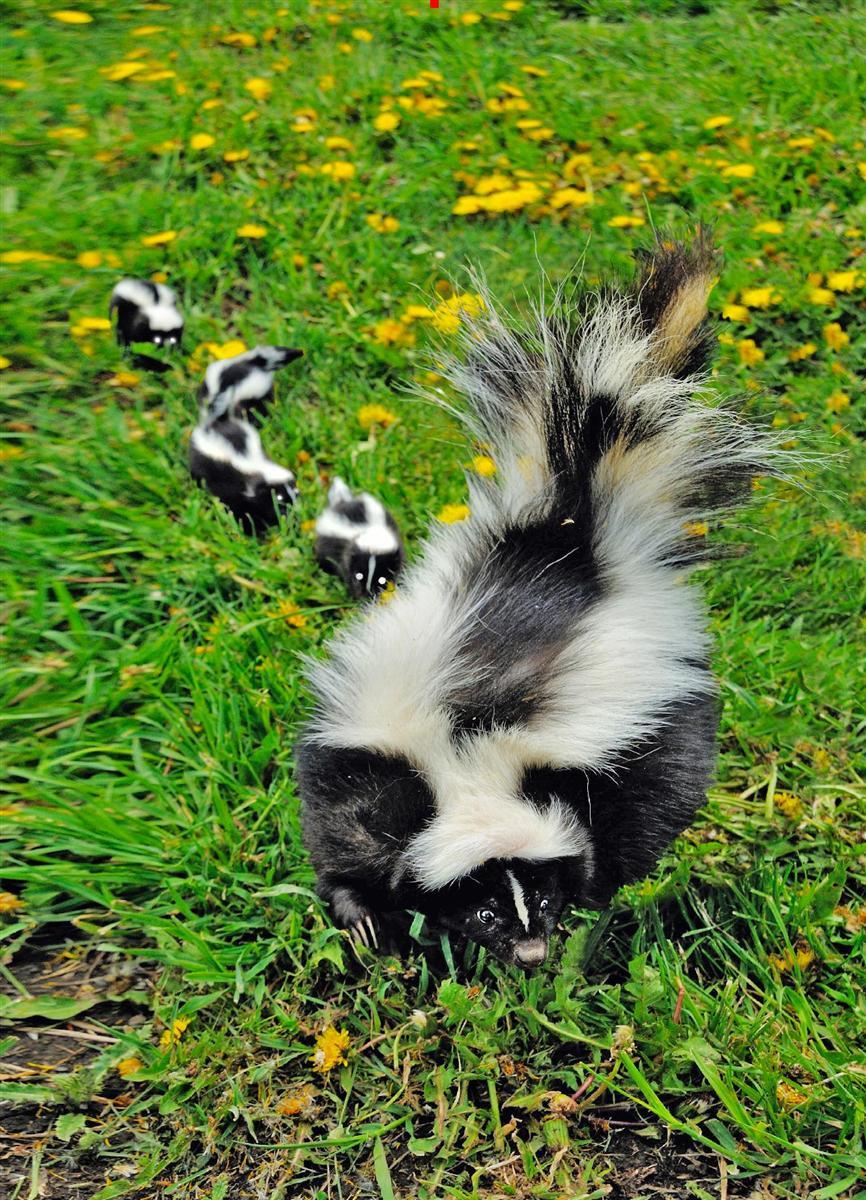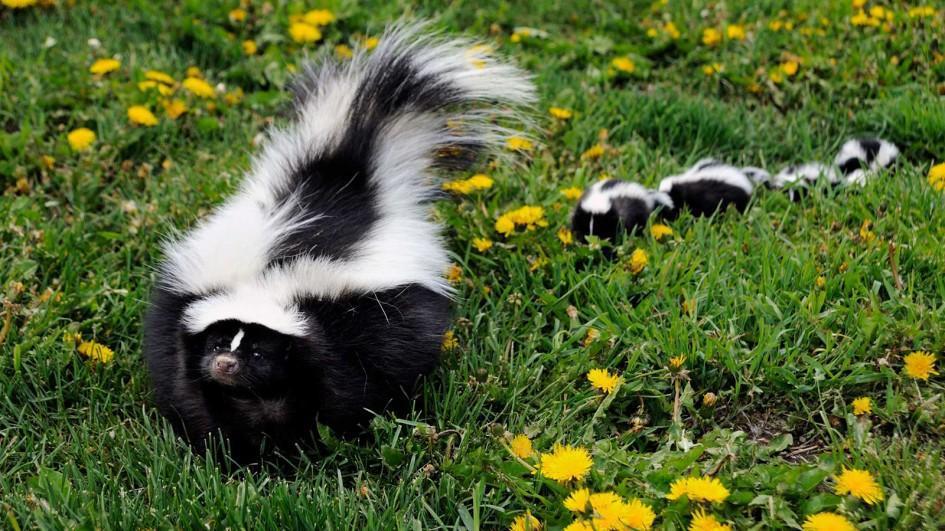The first image is the image on the left, the second image is the image on the right. For the images displayed, is the sentence "At least five similar sized skunks are lined up next to each other in the grass." factually correct? Answer yes or no. No. 